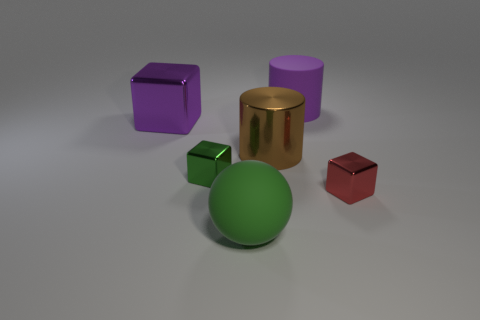Add 2 large green cylinders. How many objects exist? 8 Subtract all balls. How many objects are left? 5 Add 6 big purple shiny cubes. How many big purple shiny cubes are left? 7 Add 3 large purple shiny cylinders. How many large purple shiny cylinders exist? 3 Subtract 0 brown cubes. How many objects are left? 6 Subtract all metallic things. Subtract all tiny red cubes. How many objects are left? 1 